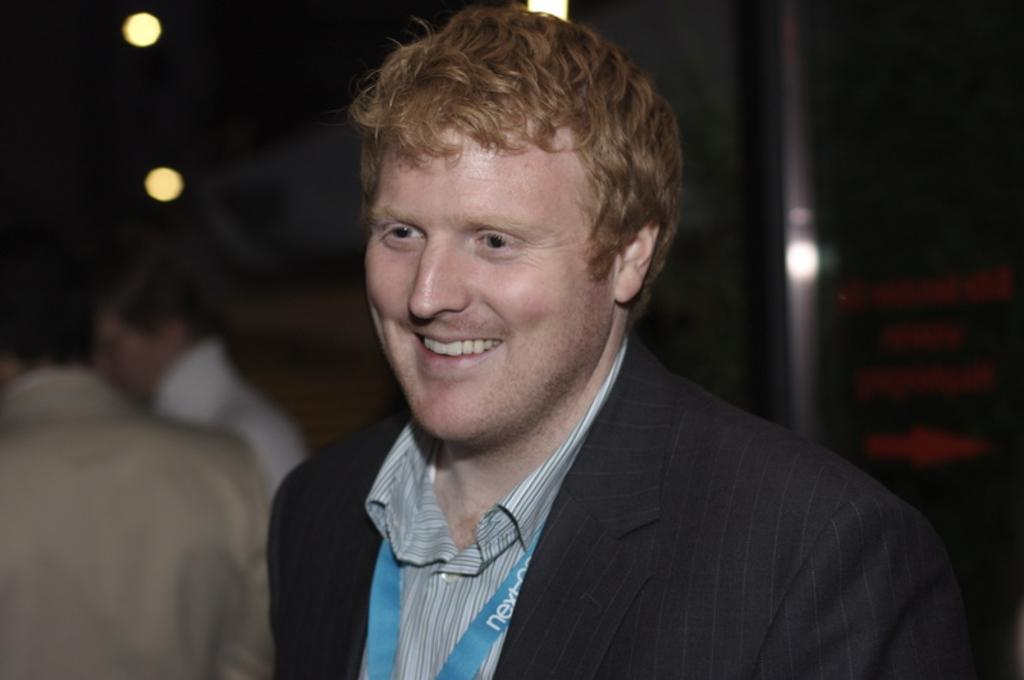Who is present in the image? There is a man in the image. What is the man wearing? The man is wearing a black suit and a blue tag. Can you describe the background of the image? The background of the image is blurred. Where are the lights located in the image? There are two lights on the left side of the image. What type of fiction is the man reading in the image? There is no book or any form of fiction present in the image. What is the condition of the tramp in the image? There is no tramp present in the image. 